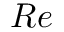Convert formula to latex. <formula><loc_0><loc_0><loc_500><loc_500>R e</formula> 